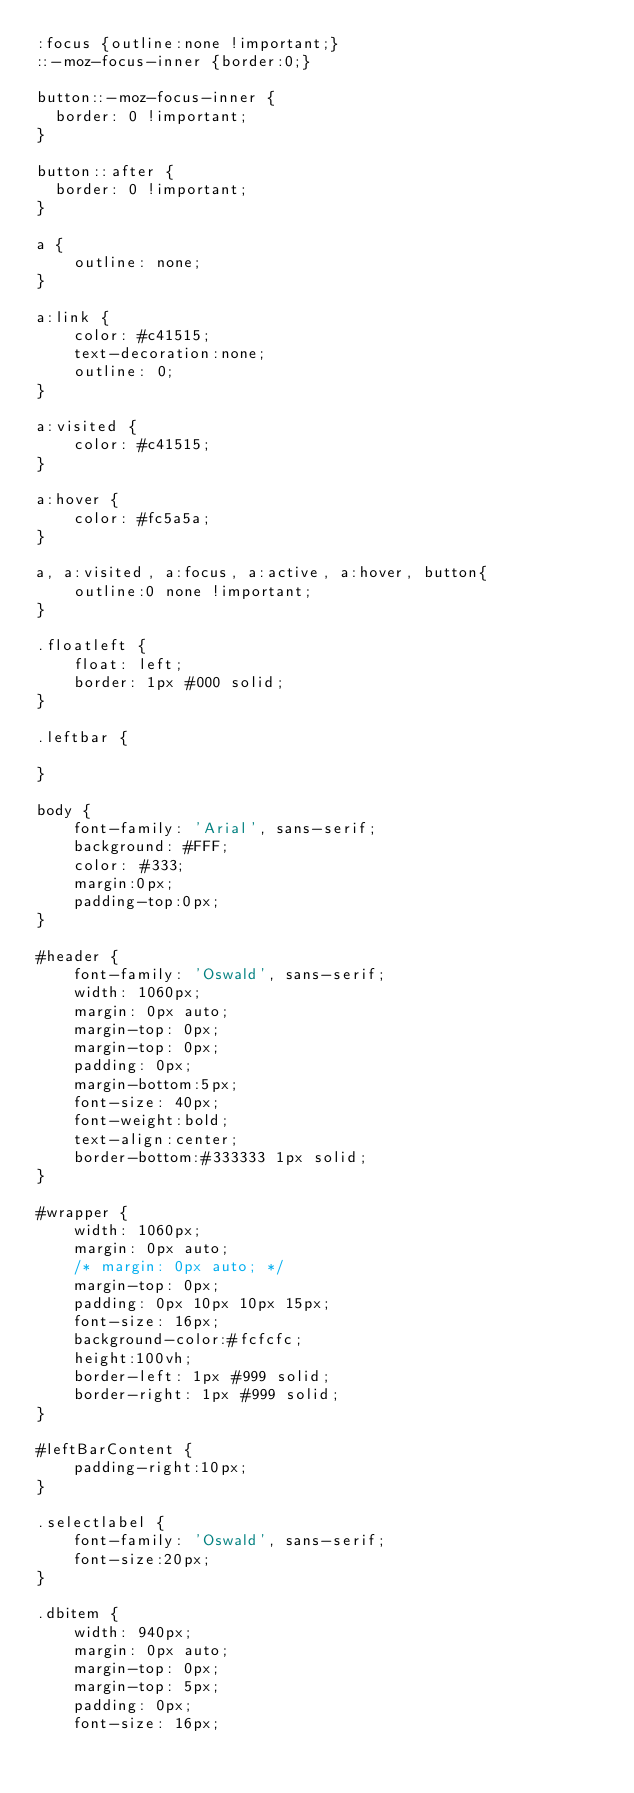Convert code to text. <code><loc_0><loc_0><loc_500><loc_500><_CSS_>:focus {outline:none !important;}
::-moz-focus-inner {border:0;}

button::-moz-focus-inner {
  border: 0 !important;
}

button::after {
  border: 0 !important;
}

a {
	outline: none;
}

a:link {
	color: #c41515;
	text-decoration:none;
	outline: 0;
}

a:visited {
	color: #c41515;
}

a:hover {
	color: #fc5a5a;
}

a, a:visited, a:focus, a:active, a:hover, button{
    outline:0 none !important;
}

.floatleft {
	float: left;
	border: 1px #000 solid;
}

.leftbar {
	
}

body {
	font-family: 'Arial', sans-serif;
	background: #FFF;
	color: #333;
	margin:0px;
	padding-top:0px;
}

#header {
	font-family: 'Oswald', sans-serif;
	width: 1060px;
	margin: 0px auto;
	margin-top: 0px;
	margin-top: 0px;
	padding: 0px;
	margin-bottom:5px;
	font-size: 40px;
	font-weight:bold;
	text-align:center;
	border-bottom:#333333 1px solid;
}

#wrapper {
	width: 1060px;
	margin: 0px auto;
	/* margin: 0px auto; */
	margin-top: 0px;
	padding: 0px 10px 10px 15px;
	font-size: 16px;
	background-color:#fcfcfc;
	height:100vh;
	border-left: 1px #999 solid;
	border-right: 1px #999 solid;
}

#leftBarContent {
	padding-right:10px;
}

.selectlabel {
	font-family: 'Oswald', sans-serif;
	font-size:20px;
}

.dbitem {
	width: 940px;
	margin: 0px auto;
	margin-top: 0px;
	margin-top: 5px;
	padding: 0px;
	font-size: 16px;</code> 